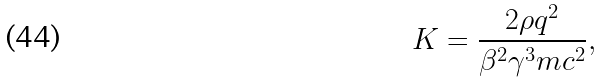Convert formula to latex. <formula><loc_0><loc_0><loc_500><loc_500>K = \frac { 2 \rho q ^ { 2 } } { \beta ^ { 2 } \gamma ^ { 3 } m c ^ { 2 } } ,</formula> 